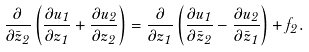<formula> <loc_0><loc_0><loc_500><loc_500>\frac { \partial } { \partial \bar { z } _ { 2 } } \left ( \frac { \partial u _ { 1 } } { \partial z _ { 1 } } + \frac { \partial u _ { 2 } } { \partial z _ { 2 } } \right ) = \frac { \partial } { \partial z _ { 1 } } \left ( \frac { \partial u _ { 1 } } { \partial \bar { z } _ { 2 } } - \frac { \partial u _ { 2 } } { \partial \bar { z } _ { 1 } } \right ) + f _ { 2 } .</formula> 